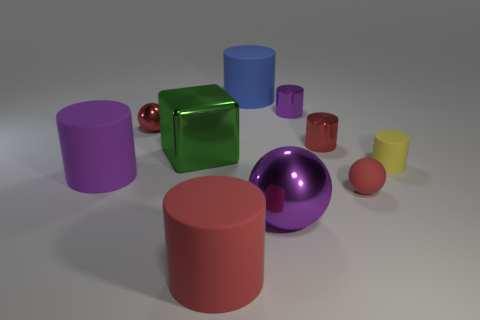Does the tiny rubber sphere have the same color as the small metal sphere?
Provide a succinct answer. Yes. There is a small object that is the same color as the large metal ball; what is its shape?
Keep it short and to the point. Cylinder. There is a metal sphere that is the same color as the small matte ball; what size is it?
Give a very brief answer. Small. How many objects are big blue shiny things or small metallic balls?
Give a very brief answer. 1. Is there a large cyan block?
Your answer should be compact. No. Is the material of the red cylinder that is right of the tiny purple object the same as the tiny purple thing?
Offer a terse response. Yes. Is there a tiny brown matte thing of the same shape as the blue object?
Keep it short and to the point. No. Are there the same number of yellow rubber cylinders that are to the left of the small purple cylinder and big blue cylinders?
Your answer should be very brief. No. There is a big blue thing that is on the right side of the red matte cylinder that is in front of the yellow rubber cylinder; what is it made of?
Keep it short and to the point. Rubber. There is a purple rubber thing; what shape is it?
Your response must be concise. Cylinder. 